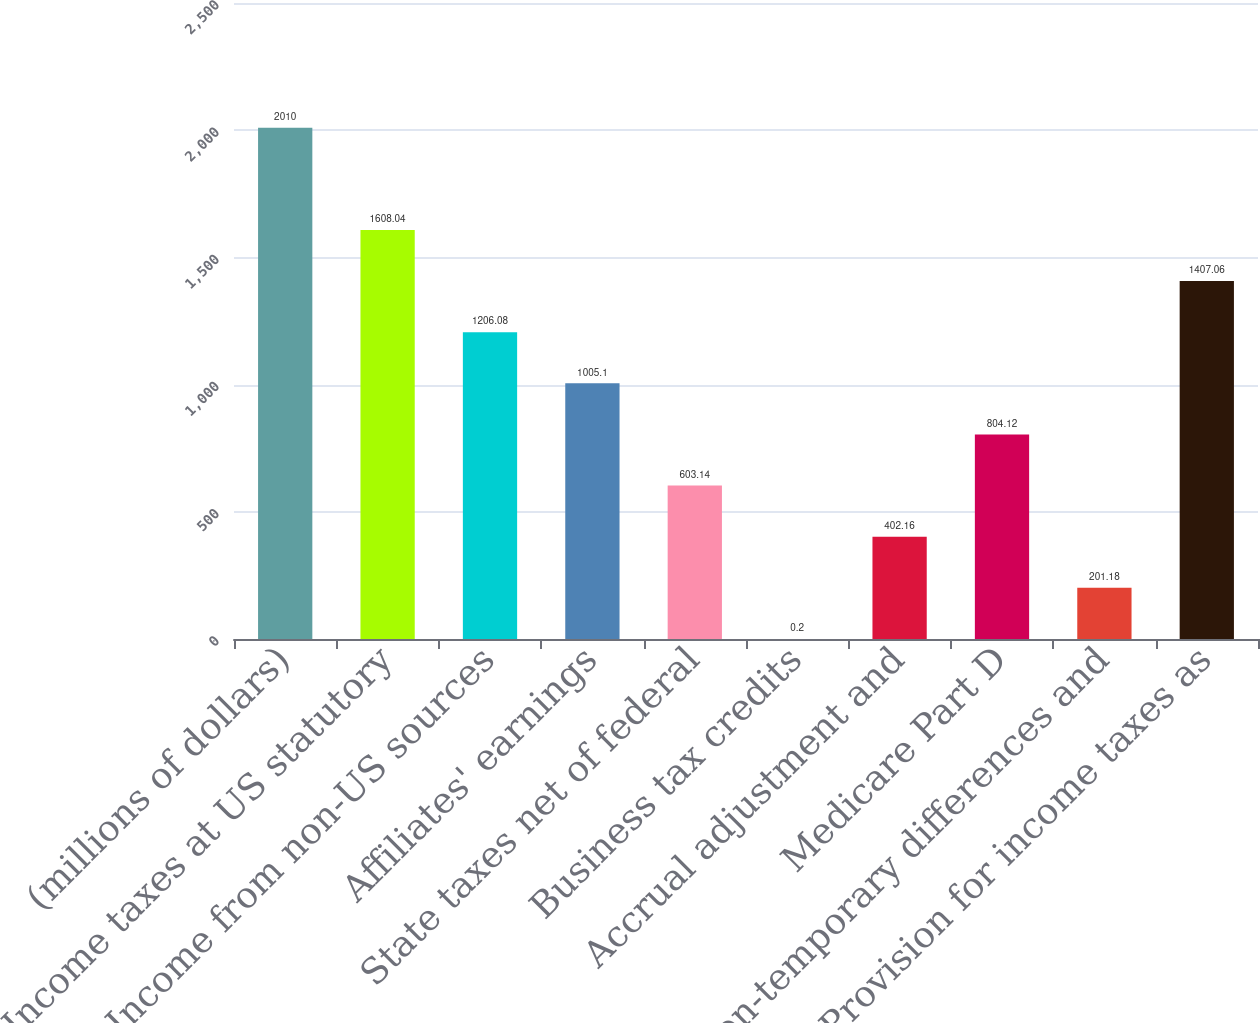<chart> <loc_0><loc_0><loc_500><loc_500><bar_chart><fcel>(millions of dollars)<fcel>Income taxes at US statutory<fcel>Income from non-US sources<fcel>Affiliates' earnings<fcel>State taxes net of federal<fcel>Business tax credits<fcel>Accrual adjustment and<fcel>Medicare Part D<fcel>Non-temporary differences and<fcel>Provision for income taxes as<nl><fcel>2010<fcel>1608.04<fcel>1206.08<fcel>1005.1<fcel>603.14<fcel>0.2<fcel>402.16<fcel>804.12<fcel>201.18<fcel>1407.06<nl></chart> 